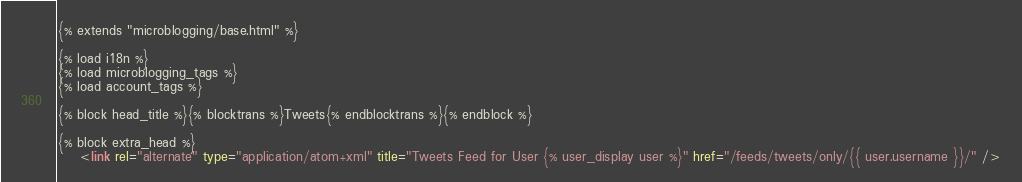Convert code to text. <code><loc_0><loc_0><loc_500><loc_500><_HTML_>{% extends "microblogging/base.html" %}

{% load i18n %}
{% load microblogging_tags %}
{% load account_tags %}

{% block head_title %}{% blocktrans %}Tweets{% endblocktrans %}{% endblock %}

{% block extra_head %}
    <link rel="alternate" type="application/atom+xml" title="Tweets Feed for User {% user_display user %}" href="/feeds/tweets/only/{{ user.username }}/" /></code> 